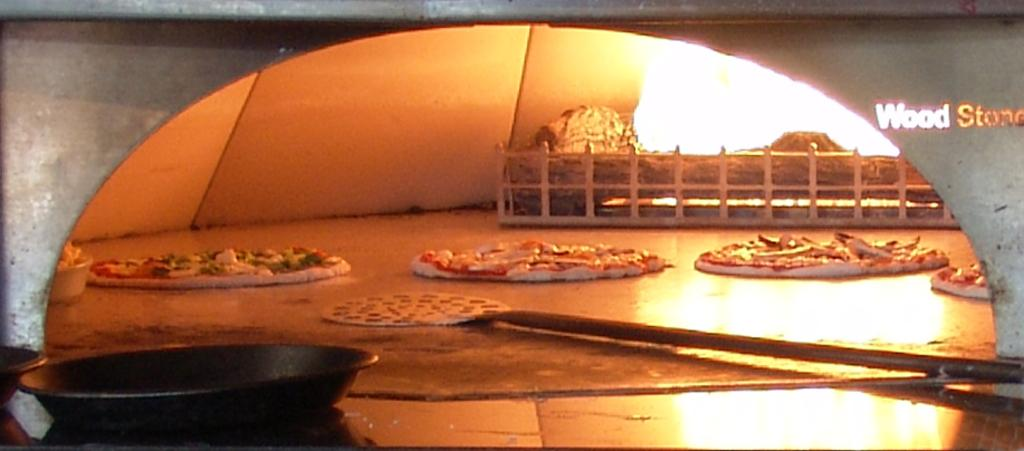<image>
Create a compact narrative representing the image presented. Oven full of pizza and the words WOOD STONE on the right. 